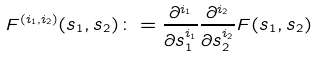<formula> <loc_0><loc_0><loc_500><loc_500>F ^ { ( i _ { 1 } , i _ { 2 } ) } ( s _ { 1 } , s _ { 2 } ) \colon = \frac { \partial ^ { i _ { 1 } } } { \partial s _ { 1 } ^ { i _ { 1 } } } \frac { \partial ^ { i _ { 2 } } } { \partial s _ { 2 } ^ { i _ { 2 } } } F ( s _ { 1 } , s _ { 2 } )</formula> 